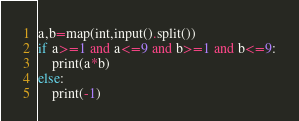Convert code to text. <code><loc_0><loc_0><loc_500><loc_500><_Python_>a,b=map(int,input().split())
if a>=1 and a<=9 and b>=1 and b<=9:
	print(a*b)
else:
	print(-1)</code> 